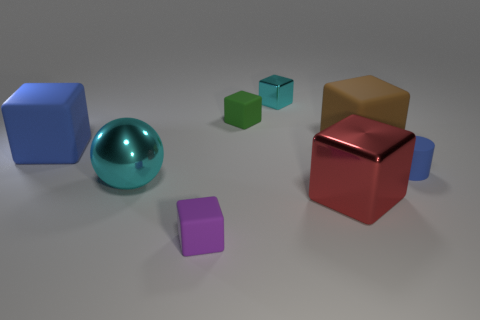What number of objects are tiny rubber cubes that are behind the purple matte thing or tiny purple things?
Offer a terse response. 2. What number of big brown cylinders are there?
Provide a succinct answer. 0. The large blue object that is made of the same material as the purple object is what shape?
Your answer should be very brief. Cube. How big is the metallic cube that is behind the big block in front of the large cyan object?
Your response must be concise. Small. What number of things are either shiny things that are right of the purple block or metal things that are on the left side of the cyan cube?
Your answer should be compact. 3. Is the number of purple rubber things less than the number of small cyan spheres?
Your response must be concise. No. What number of objects are yellow matte cubes or metallic things?
Give a very brief answer. 3. Does the red object have the same shape as the green object?
Provide a short and direct response. Yes. Is there anything else that has the same material as the big brown object?
Your answer should be very brief. Yes. There is a metal block that is in front of the brown matte cube; is its size the same as the matte object that is in front of the blue rubber cylinder?
Make the answer very short. No. 